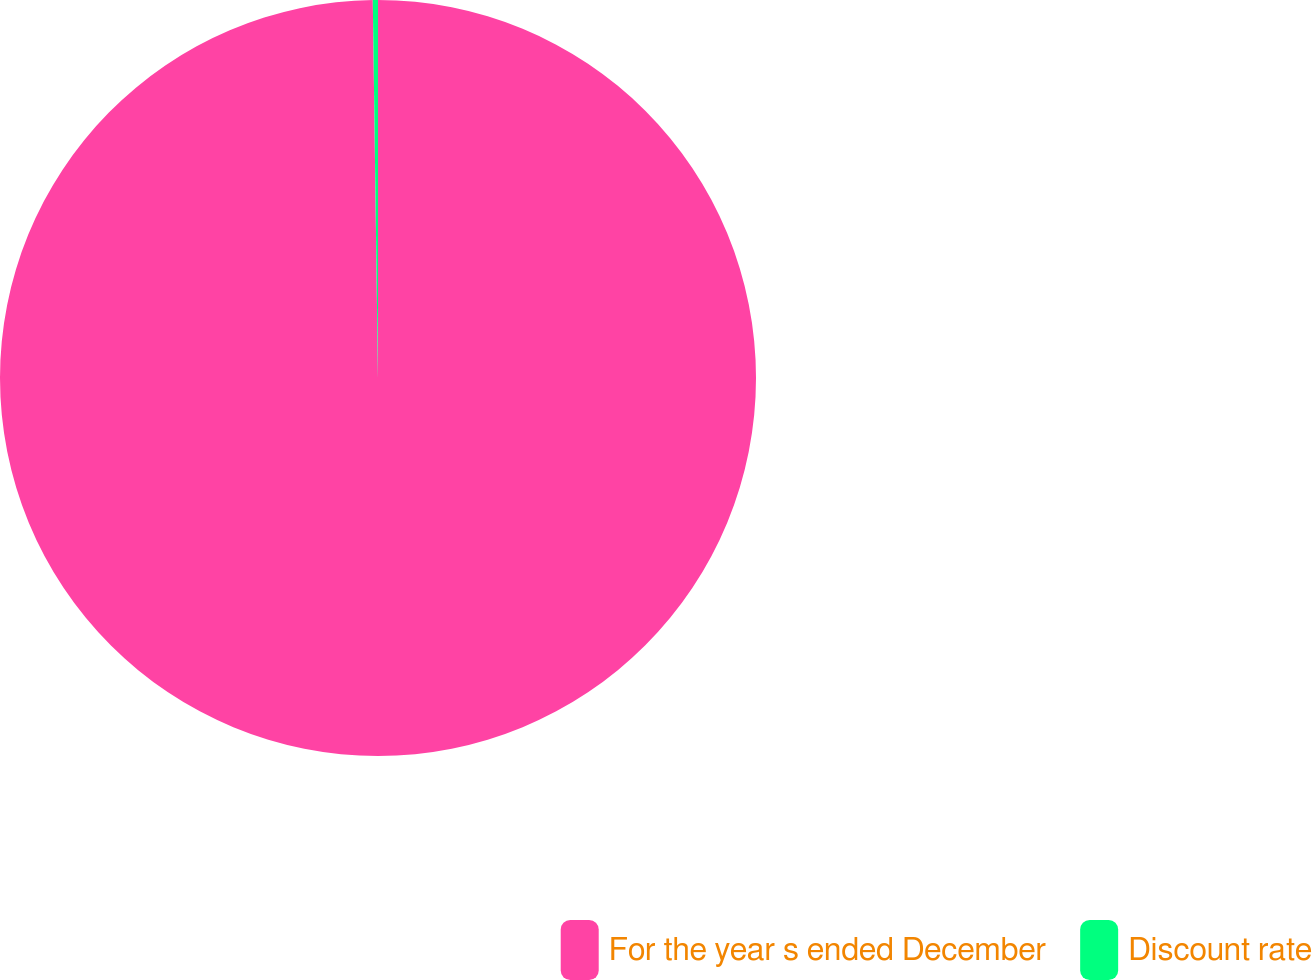Convert chart. <chart><loc_0><loc_0><loc_500><loc_500><pie_chart><fcel>For the year s ended December<fcel>Discount rate<nl><fcel>99.78%<fcel>0.22%<nl></chart> 